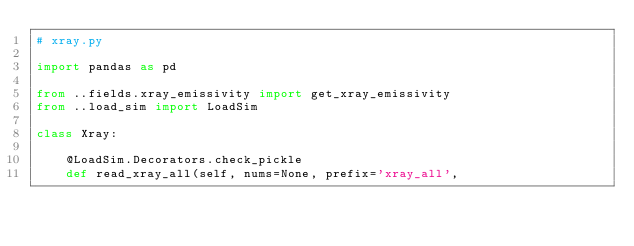<code> <loc_0><loc_0><loc_500><loc_500><_Python_># xray.py

import pandas as pd

from ..fields.xray_emissivity import get_xray_emissivity
from ..load_sim import LoadSim

class Xray:
    
    @LoadSim.Decorators.check_pickle
    def read_xray_all(self, nums=None, prefix='xray_all',</code> 